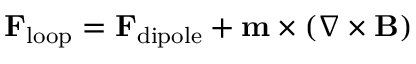Convert formula to latex. <formula><loc_0><loc_0><loc_500><loc_500>F _ { l o o p } = F _ { d i p o l e } + m \times \left ( \nabla \times B \right )</formula> 